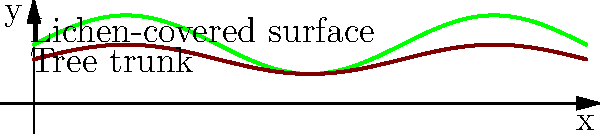A poet observes a lichen-covered tree trunk in a forest. The trunk's radius (in centimeters) varies along its height according to the function $r(x) = 2 + \sin(\frac{x}{2})$, where $x$ is the height in centimeters from the ground. The lichen growth adds an additional thickness described by the function $t(x) = 0.5 + 0.5\sin(\frac{x}{2})$. Calculate the volume of the lichen-covered trunk from the ground up to a height of 3π cm. To solve this problem, we'll follow these steps:

1) The volume of a solid of revolution is given by the formula:
   $$V = \pi \int_a^b [R(x)]^2 dx$$
   where $R(x)$ is the outer radius of the solid.

2) In this case, $R(x) = r(x) + t(x)$, so:
   $$R(x) = (2 + \sin(\frac{x}{2})) + (0.5 + 0.5\sin(\frac{x}{2}))$$
   $$R(x) = 2.5 + 1.5\sin(\frac{x}{2})$$

3) Now we can set up our integral:
   $$V = \pi \int_0^{3\pi} [2.5 + 1.5\sin(\frac{x}{2})]^2 dx$$

4) Expand the squared term:
   $$V = \pi \int_0^{3\pi} [6.25 + 7.5\sin(\frac{x}{2}) + 2.25\sin^2(\frac{x}{2})] dx$$

5) Integrate each term:
   $$V = \pi [6.25x - 15\cos(\frac{x}{2}) + \frac{9}{8}x - \frac{9}{16}\sin(x)]_0^{3\pi}$$

6) Evaluate the integral:
   $$V = \pi [(6.25 + \frac{9}{8})(3\pi) - 15(\cos(\frac{3\pi}{2}) - 1) - \frac{9}{16}(\sin(3\pi) - \sin(0))]$$
   $$V = \pi [22.03125\pi + 30]$$

7) Simplify:
   $$V \approx 224.78 \text{ cm}^3$$
Answer: $224.78 \text{ cm}^3$ 